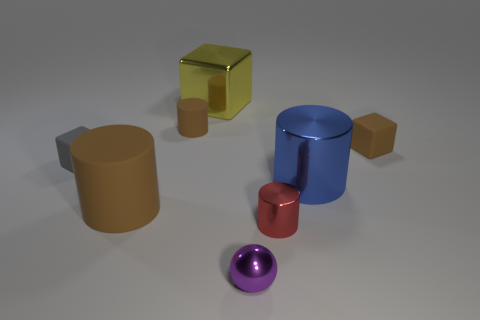Subtract all small brown matte blocks. How many blocks are left? 2 Add 2 large rubber objects. How many objects exist? 10 Subtract all red cylinders. How many cylinders are left? 3 Subtract all balls. How many objects are left? 7 Subtract 2 blocks. How many blocks are left? 1 Subtract all green cubes. Subtract all yellow cylinders. How many cubes are left? 3 Subtract all cyan cubes. How many blue cylinders are left? 1 Subtract all large shiny objects. Subtract all brown things. How many objects are left? 3 Add 7 tiny red things. How many tiny red things are left? 8 Add 4 yellow things. How many yellow things exist? 5 